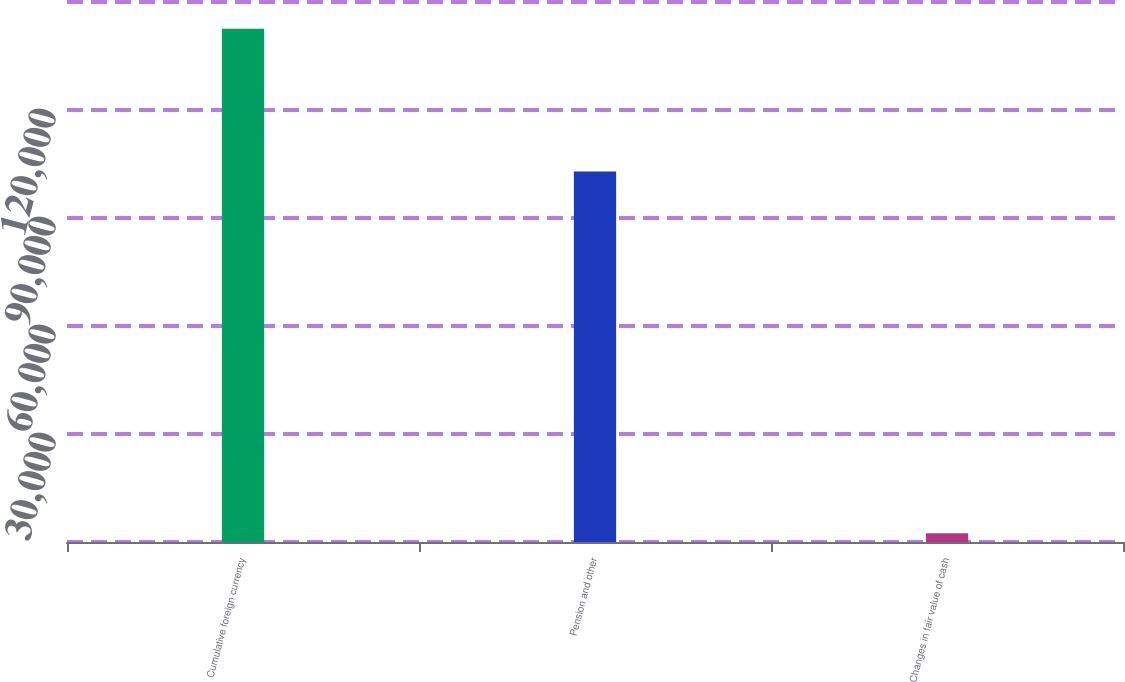Convert chart. <chart><loc_0><loc_0><loc_500><loc_500><bar_chart><fcel>Cumulative foreign currency<fcel>Pension and other<fcel>Changes in fair value of cash<nl><fcel>142567<fcel>102932<fcel>2403<nl></chart> 